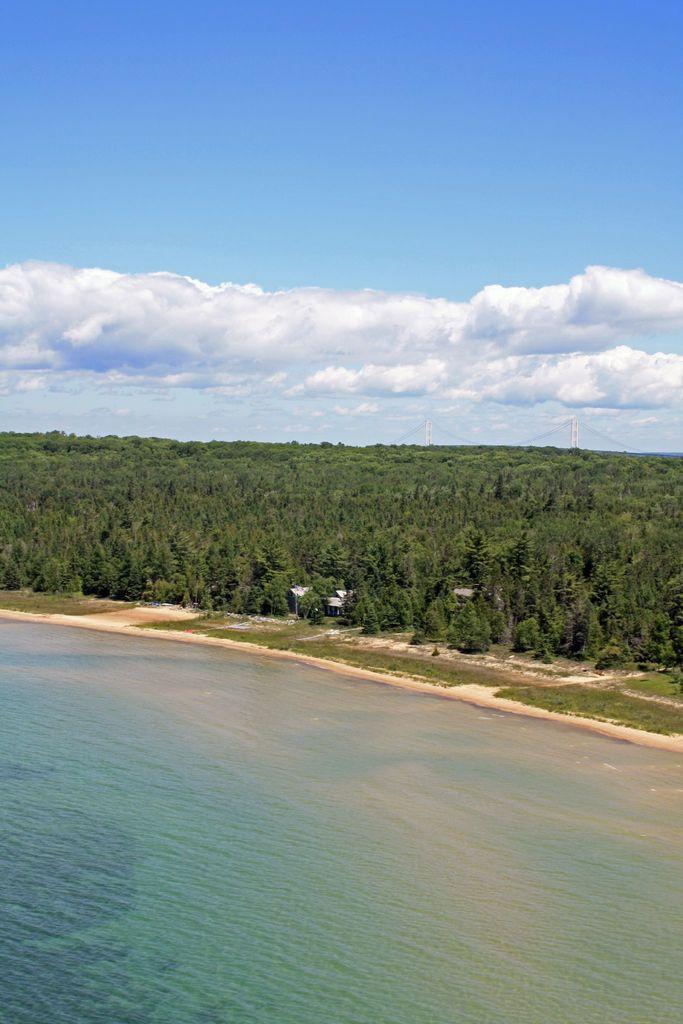In one or two sentences, can you explain what this image depicts? In this picture we can see trees, water, grass and in the background we can see the sky with clouds. 